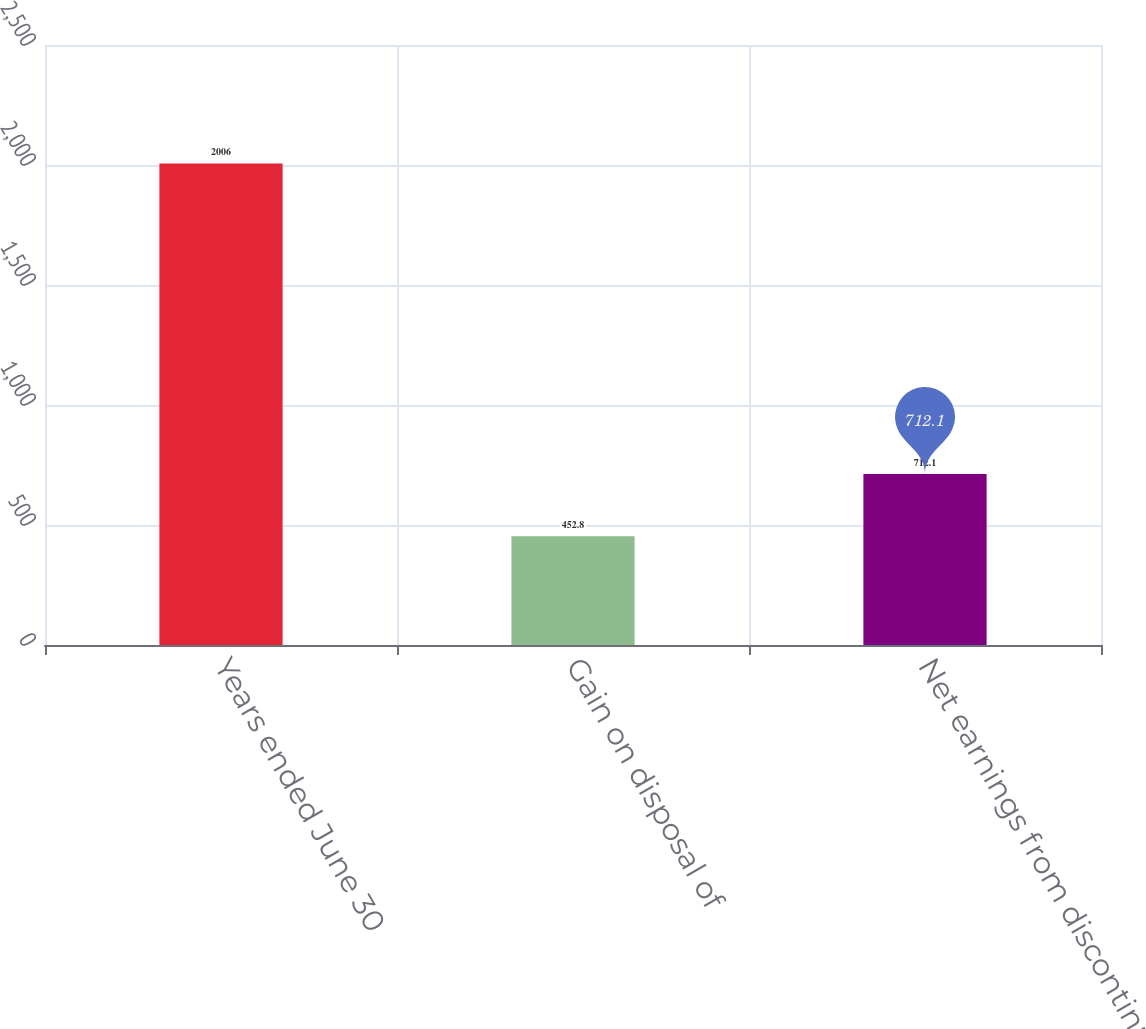Convert chart. <chart><loc_0><loc_0><loc_500><loc_500><bar_chart><fcel>Years ended June 30<fcel>Gain on disposal of<fcel>Net earnings from discontinued<nl><fcel>2006<fcel>452.8<fcel>712.1<nl></chart> 